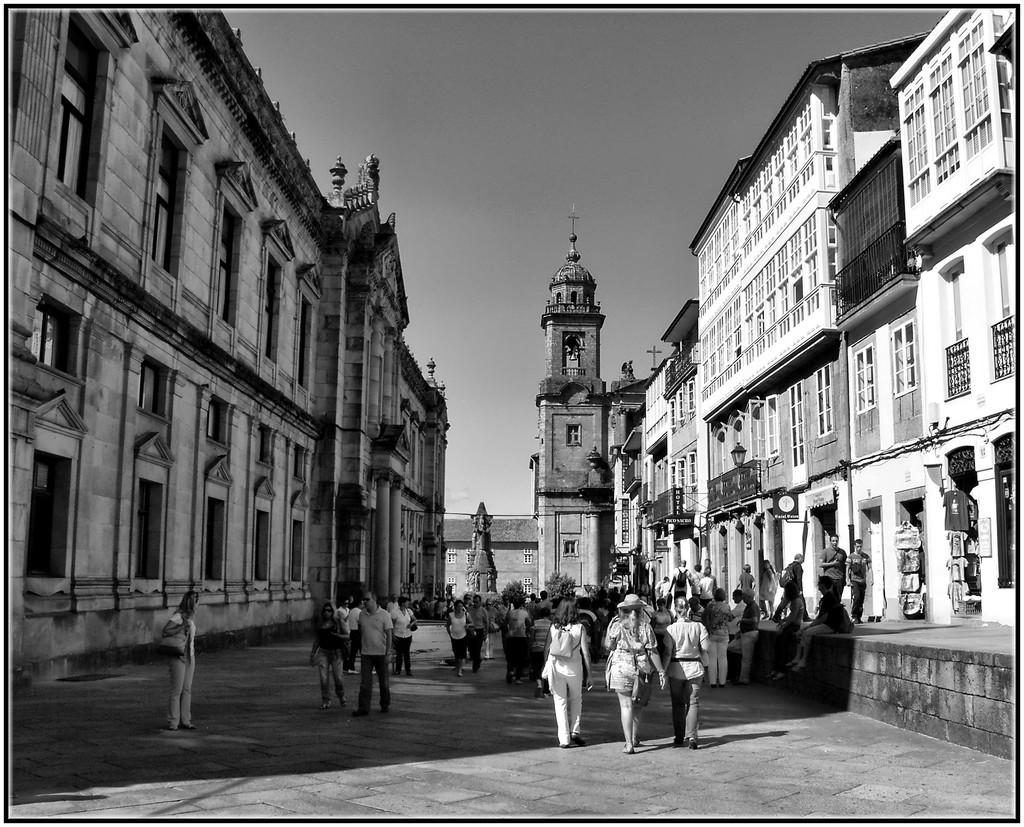What is the color scheme of the image? The image is black and white. What type of structures can be seen in the image? There are buildings in the image. What can be seen illuminating the scene? There are lights visible in the image. Who or what is present in the image? There are people in the image. What architectural features are visible on the buildings? There are windows in the image. What type of barrier is present in the image? There is a grille in the image. What is visible in the background of the image? The sky is visible in the background of the image. What type of rod can be seen holding up the grain in the image? There is no rod or grain present in the image. What type of quiver is visible on the person's back in the image? There are no people carrying quivers in the image. 